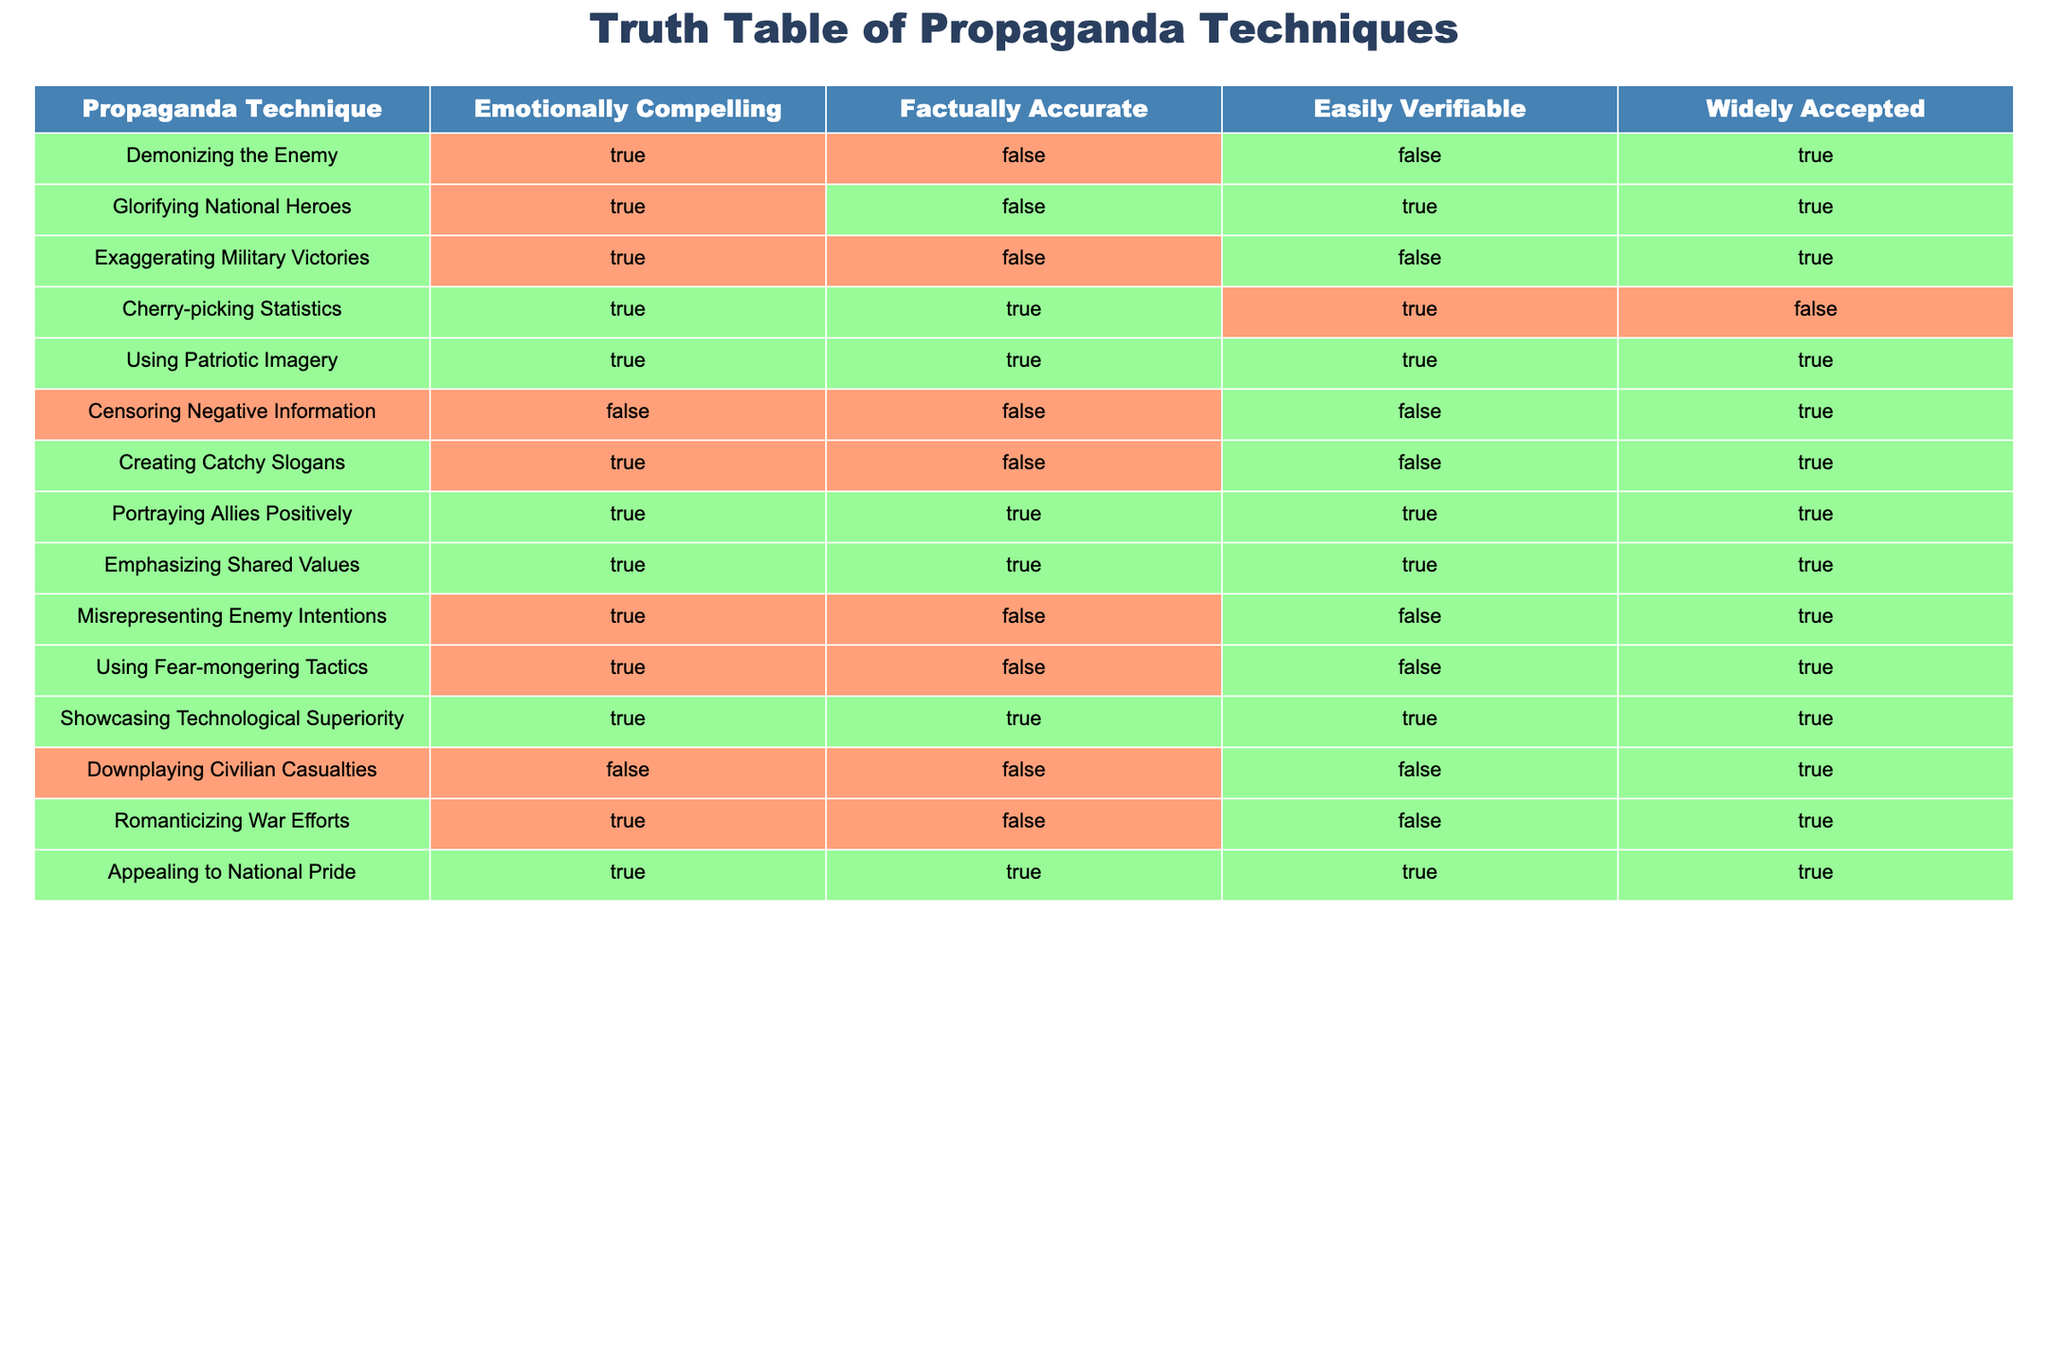What is the truth value of "Exaggerating Military Victories" in terms of being factually accurate? According to the table, the truth value for "Exaggerating Military Victories" under "Factually Accurate" is FALSE.
Answer: FALSE Which propaganda technique is both emotionally compelling and easily verifiable? By examining the table, "Cherry-picking Statistics" is the only technique that is marked TRUE for both "Emotionally Compelling" and "Easily Verifiable."
Answer: Cherry-picking Statistics How many propaganda techniques are factually accurate? The techniques that are marked TRUE in the "Factually Accurate" column are "Cherry-picking Statistics," "Using Patriotic Imagery," "Portraying Allies Positively," "Emphasizing Shared Values," and "Showcasing Technological Superiority." This totals to 5 techniques.
Answer: 5 Is "Censoring Negative Information" emotionally compelling? The truth value for "Censoring Negative Information" in the "Emotionally Compelling" category is FALSE as shown in the table.
Answer: FALSE Which propaganda technique has the most positive truth values? By analyzing the table, "Using Patriotic Imagery," "Portraying Allies Positively," "Emphasizing Shared Values," and "Showcasing Technological Superiority" all have truth values of TRUE in all relevant columns (Emotionally Compelling, Factually Accurate, Easily Verifiable). Hence, they each have the most positive truth values.
Answer: Using Patriotic Imagery, Portraying Allies Positively, Emphasizing Shared Values, Showcasing Technological Superiority How many techniques involve fear-mongering tactics? The only technique that mentions fear-mongering is "Using Fear-mongering Tactics," which has the truth value TRUE for "Emotionally Compelling" but FALSE for the others. Therefore, there is one technique that involves fear-mongering tactics.
Answer: 1 What is the difference in truth values between "Glorifying National Heroes" and "Romanticizing War Efforts" for the column “Easily Verifiable”? "Glorifying National Heroes" has TRUE in the "Easily Verifiable" column, while "Romanticizing War Efforts" has FALSE. Hence, the difference is TRUE for "Glorifying National Heroes" and FALSE for "Romanticizing War Efforts," indicating a difference of one technique that is not easily verifiable.
Answer: 1 Is it true that all techniques that downplay negative aspects of warfare are factually accurate? By reviewing the techniques in the table, none of those techniques marked as downplaying negative aspects (like "Censoring Negative Information" and "Downplaying Civilian Casualties") have a truth value of TRUE under "Factually Accurate." Therefore, it is false that all such techniques are factually accurate.
Answer: FALSE 